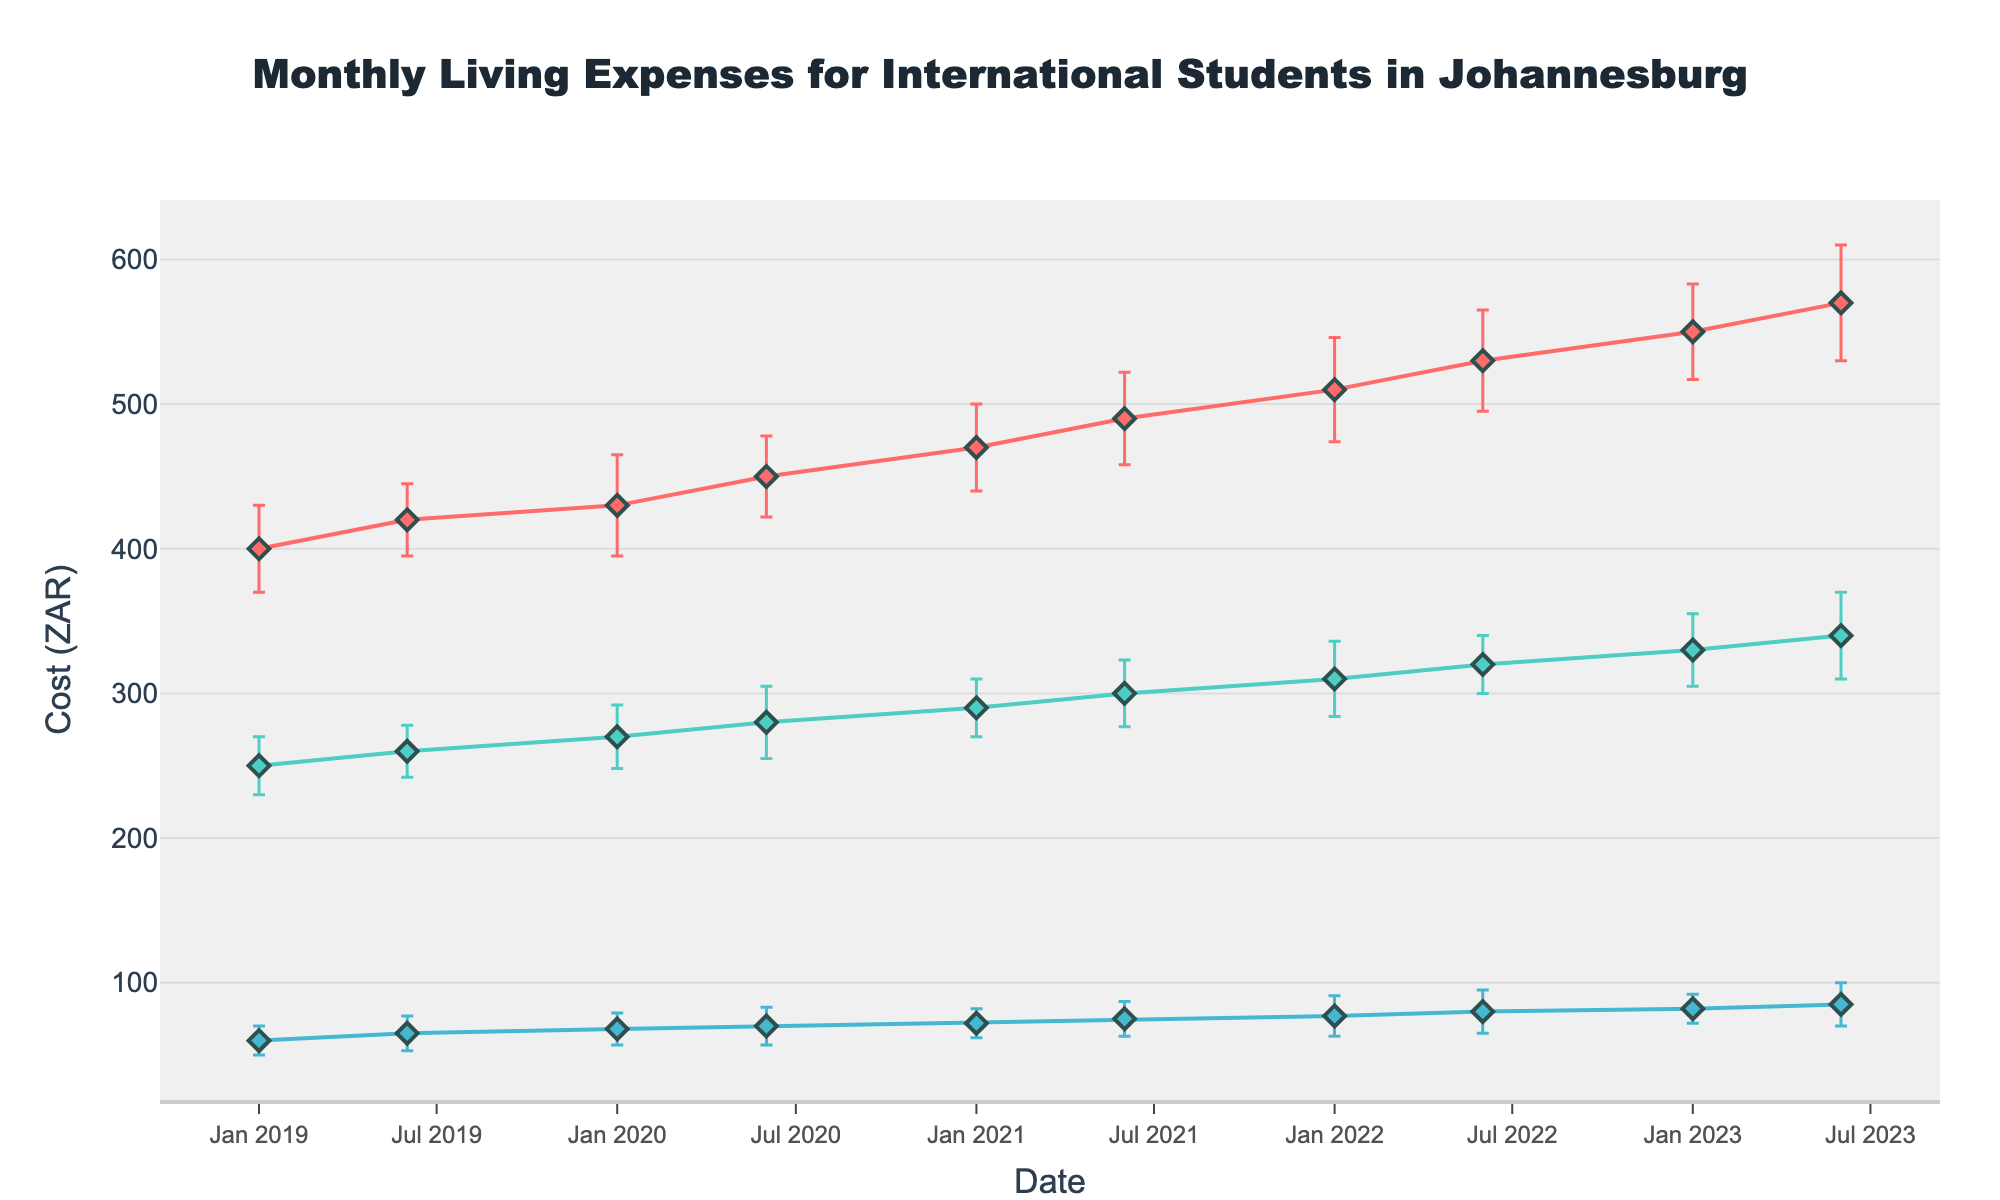What is the title of the figure? The title is located at the top of the figure and is usually large and centered. In this case, the title reads: "Monthly Living Expenses for International Students in Johannesburg".
Answer: Monthly Living Expenses for International Students in Johannesburg Which category has the highest cost in January 2023? By inspecting the data points for January 2023, you can see that the Housing category has the highest cost, followed by Food and then Transportation. The exact costs for Housing, Food, and Transportation are 550, 330, and 82, respectively.
Answer: Housing What is the average monthly cost for Food in 2021? To find the average, we take the cost for Food in January and June 2021 and calculate the mean. The costs are 290 and 300, respectively. The average is (290 + 300) / 2 = 295.
Answer: 295 By how much did the Transportation cost increase from January 2019 to June 2023? First, find the costs for Transportation in January 2019 and June 2023, which are 60 and 85, respectively. The increase is 85 - 60 = 25.
Answer: 25 Which category shows the largest error bar in any month, and what is the corresponding error value? By examining the length of the error bars, we see the largest error bar is for Housing in June 2023 with an error value of 40.
Answer: Housing, 40 Which year shows the highest overall expense for Food, and what is the value? To find the highest overall expense for Food, compare the highest data points for Food across the years. The highest value is in June 2023, with a cost of 340.
Answer: 2023, 340 On which date does the cost for Housing exceed 500 for the first time, and what is the amount? By checking the data points for Housing over time, the first time it exceeds 500 is in January 2022 with a cost of 510.
Answer: January 2022, 510 What is the difference in the average annual transportation costs between 2019 and 2023? Calculate the average transportation cost for each year. For 2019, the average is (60 + 65) / 2 = 62.5. For 2023, the average is (82 + 85) / 2 = 83.5. The difference is 83.5 - 62.5 = 21.
Answer: 21 Between Housing and Food, which category had a higher increase in cost from January 2019 to June 2023? Calculate the increase for both categories. For Housing, the costs in January 2019 and June 2023 are 400 and 570, resulting in an increase of 170. For Food, the costs are 250 and 340, resulting in an increase of 90. Housing had a higher increase.
Answer: Housing 